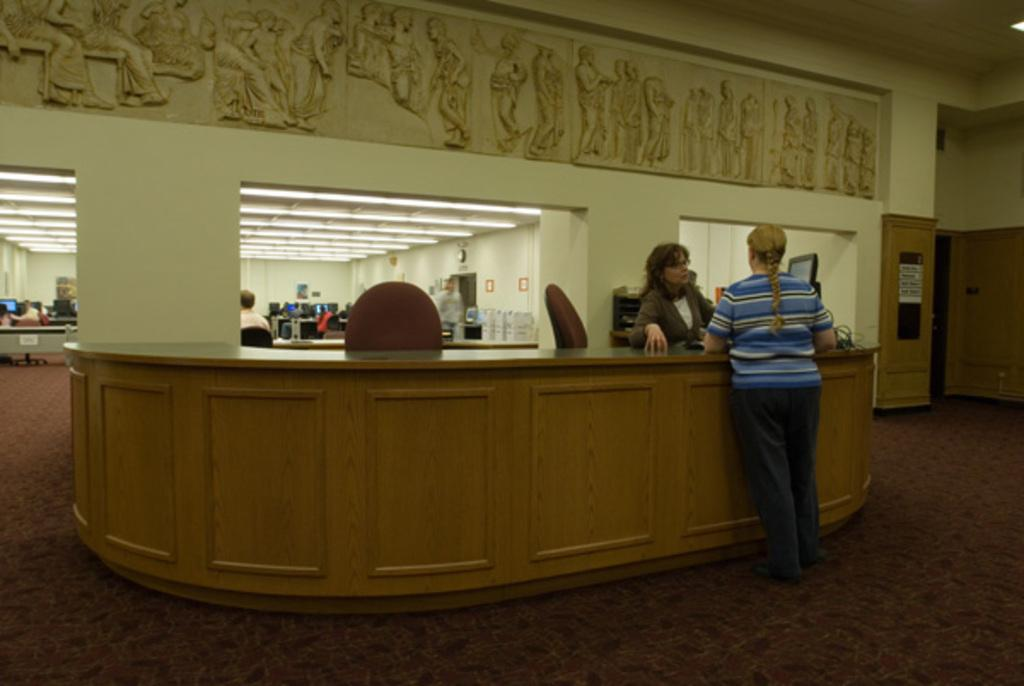How many people are in the image? There are two women in the image. What are the women doing in the image? The women are standing and speaking to each other. Are there any furniture items in the image? Yes, there are chairs in the image. What can be seen on the wall in the image? There is a sculpture on the wall in the image. What type of pest can be seen crawling on the floor in the image? There is no pest visible on the floor in the image. Can you tell me what prose the women are reciting to each other in the image? There is no indication in the image that the women are reciting any prose; they are simply speaking to each other. 